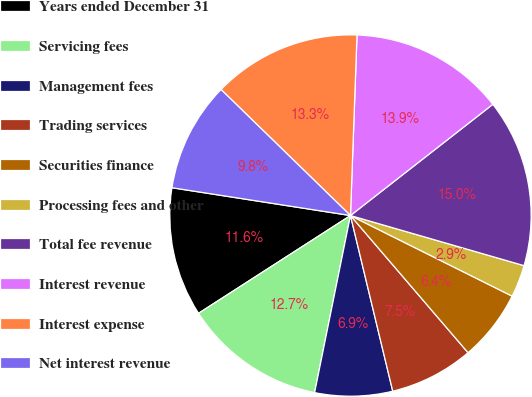<chart> <loc_0><loc_0><loc_500><loc_500><pie_chart><fcel>Years ended December 31<fcel>Servicing fees<fcel>Management fees<fcel>Trading services<fcel>Securities finance<fcel>Processing fees and other<fcel>Total fee revenue<fcel>Interest revenue<fcel>Interest expense<fcel>Net interest revenue<nl><fcel>11.56%<fcel>12.72%<fcel>6.94%<fcel>7.52%<fcel>6.36%<fcel>2.89%<fcel>15.03%<fcel>13.87%<fcel>13.29%<fcel>9.83%<nl></chart> 